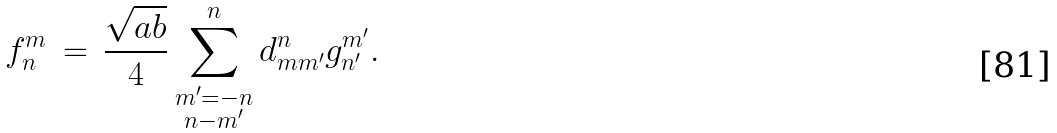<formula> <loc_0><loc_0><loc_500><loc_500>f ^ { m } _ { n } \, = \, \frac { \sqrt { a b } } { 4 } \sum _ { \substack { m ^ { \prime } = - n \\ n - m ^ { \prime } } } ^ { n } d _ { m m ^ { \prime } } ^ { n } g _ { n ^ { \prime } } ^ { m ^ { \prime } } .</formula> 